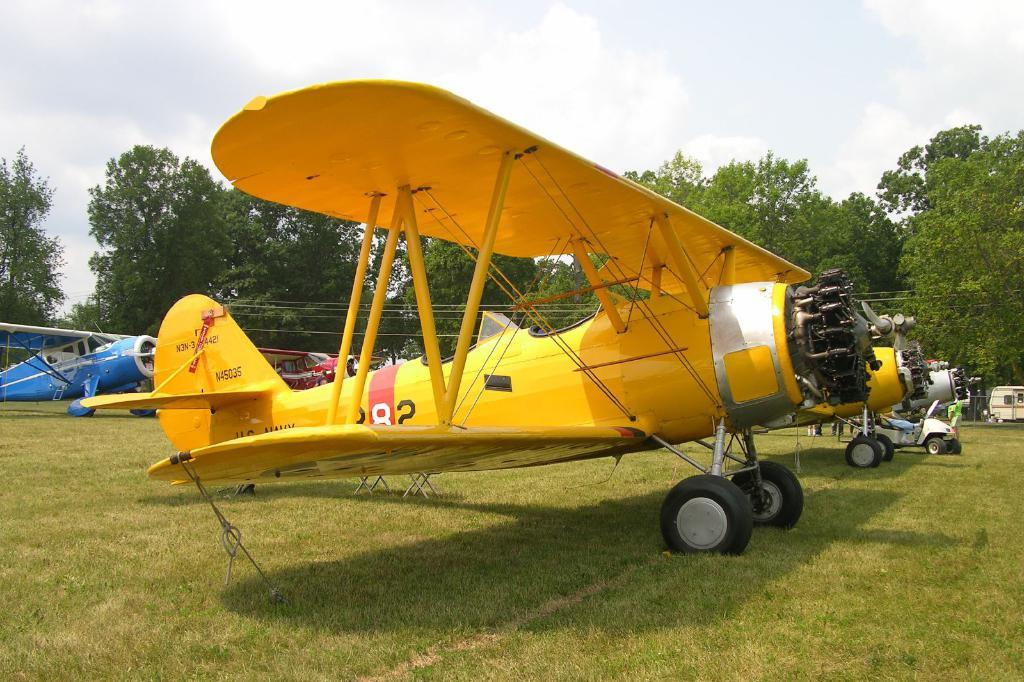<image>
Present a compact description of the photo's key features. A yellow old fashioned plane with the number 8 in red background on the side 